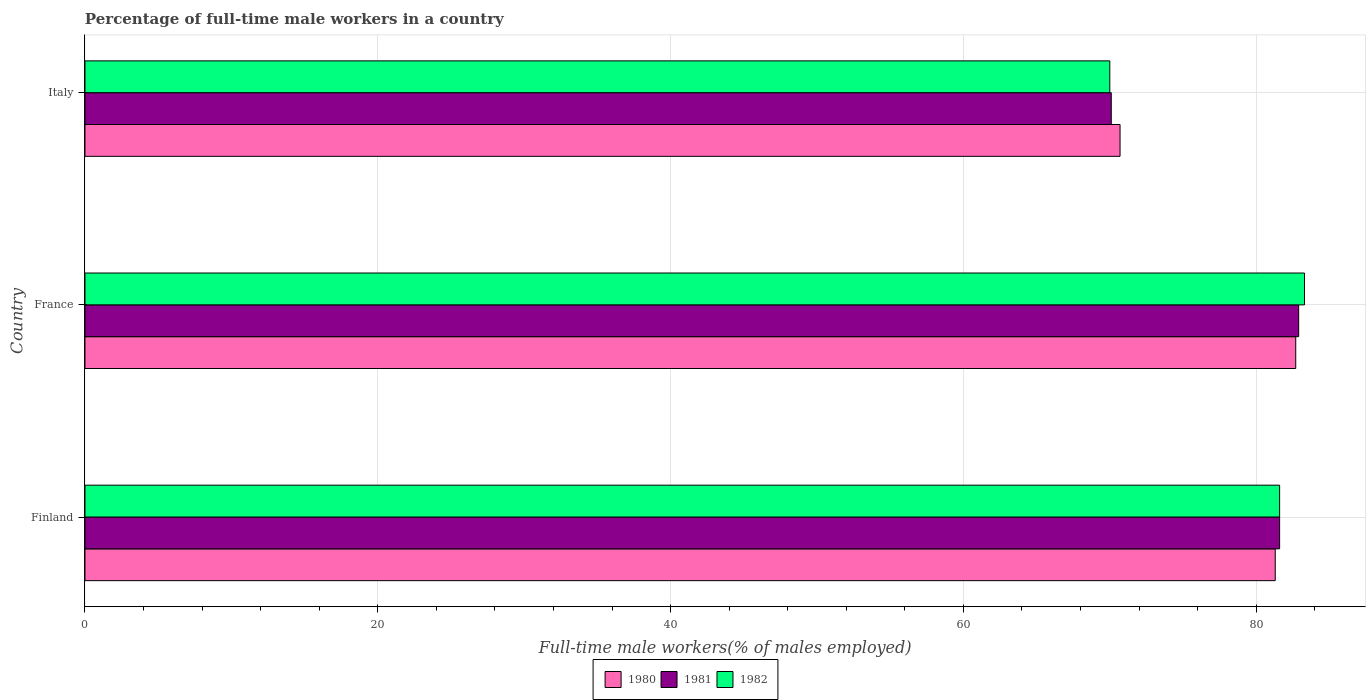How many different coloured bars are there?
Make the answer very short. 3. How many groups of bars are there?
Your response must be concise. 3. Are the number of bars per tick equal to the number of legend labels?
Give a very brief answer. Yes. How many bars are there on the 1st tick from the bottom?
Provide a short and direct response. 3. What is the label of the 3rd group of bars from the top?
Offer a very short reply. Finland. In how many cases, is the number of bars for a given country not equal to the number of legend labels?
Your answer should be very brief. 0. What is the percentage of full-time male workers in 1981 in Italy?
Keep it short and to the point. 70.1. Across all countries, what is the maximum percentage of full-time male workers in 1982?
Provide a succinct answer. 83.3. Across all countries, what is the minimum percentage of full-time male workers in 1981?
Provide a short and direct response. 70.1. In which country was the percentage of full-time male workers in 1982 maximum?
Your answer should be compact. France. What is the total percentage of full-time male workers in 1981 in the graph?
Make the answer very short. 234.6. What is the difference between the percentage of full-time male workers in 1981 in Finland and that in Italy?
Keep it short and to the point. 11.5. What is the difference between the percentage of full-time male workers in 1982 in Italy and the percentage of full-time male workers in 1981 in France?
Your answer should be compact. -12.9. What is the average percentage of full-time male workers in 1981 per country?
Offer a very short reply. 78.2. What is the difference between the percentage of full-time male workers in 1980 and percentage of full-time male workers in 1982 in Italy?
Your answer should be compact. 0.7. What is the ratio of the percentage of full-time male workers in 1980 in France to that in Italy?
Make the answer very short. 1.17. Is the percentage of full-time male workers in 1982 in Finland less than that in Italy?
Offer a terse response. No. What is the difference between the highest and the second highest percentage of full-time male workers in 1980?
Make the answer very short. 1.4. What is the difference between the highest and the lowest percentage of full-time male workers in 1982?
Your response must be concise. 13.3. Is the sum of the percentage of full-time male workers in 1982 in Finland and France greater than the maximum percentage of full-time male workers in 1981 across all countries?
Offer a terse response. Yes. What does the 3rd bar from the top in Finland represents?
Keep it short and to the point. 1980. What does the 3rd bar from the bottom in Italy represents?
Ensure brevity in your answer.  1982. What is the difference between two consecutive major ticks on the X-axis?
Provide a succinct answer. 20. Are the values on the major ticks of X-axis written in scientific E-notation?
Ensure brevity in your answer.  No. How many legend labels are there?
Give a very brief answer. 3. How are the legend labels stacked?
Make the answer very short. Horizontal. What is the title of the graph?
Provide a succinct answer. Percentage of full-time male workers in a country. What is the label or title of the X-axis?
Keep it short and to the point. Full-time male workers(% of males employed). What is the Full-time male workers(% of males employed) of 1980 in Finland?
Offer a terse response. 81.3. What is the Full-time male workers(% of males employed) in 1981 in Finland?
Make the answer very short. 81.6. What is the Full-time male workers(% of males employed) in 1982 in Finland?
Offer a very short reply. 81.6. What is the Full-time male workers(% of males employed) of 1980 in France?
Make the answer very short. 82.7. What is the Full-time male workers(% of males employed) of 1981 in France?
Provide a short and direct response. 82.9. What is the Full-time male workers(% of males employed) of 1982 in France?
Offer a terse response. 83.3. What is the Full-time male workers(% of males employed) in 1980 in Italy?
Make the answer very short. 70.7. What is the Full-time male workers(% of males employed) of 1981 in Italy?
Your answer should be compact. 70.1. What is the Full-time male workers(% of males employed) of 1982 in Italy?
Make the answer very short. 70. Across all countries, what is the maximum Full-time male workers(% of males employed) in 1980?
Give a very brief answer. 82.7. Across all countries, what is the maximum Full-time male workers(% of males employed) in 1981?
Make the answer very short. 82.9. Across all countries, what is the maximum Full-time male workers(% of males employed) in 1982?
Make the answer very short. 83.3. Across all countries, what is the minimum Full-time male workers(% of males employed) in 1980?
Provide a short and direct response. 70.7. Across all countries, what is the minimum Full-time male workers(% of males employed) of 1981?
Provide a succinct answer. 70.1. Across all countries, what is the minimum Full-time male workers(% of males employed) in 1982?
Offer a very short reply. 70. What is the total Full-time male workers(% of males employed) in 1980 in the graph?
Your answer should be very brief. 234.7. What is the total Full-time male workers(% of males employed) in 1981 in the graph?
Ensure brevity in your answer.  234.6. What is the total Full-time male workers(% of males employed) in 1982 in the graph?
Your response must be concise. 234.9. What is the difference between the Full-time male workers(% of males employed) in 1980 in Finland and that in Italy?
Give a very brief answer. 10.6. What is the difference between the Full-time male workers(% of males employed) in 1982 in Finland and that in Italy?
Offer a very short reply. 11.6. What is the difference between the Full-time male workers(% of males employed) of 1980 in France and that in Italy?
Offer a very short reply. 12. What is the difference between the Full-time male workers(% of males employed) of 1982 in France and that in Italy?
Your answer should be compact. 13.3. What is the difference between the Full-time male workers(% of males employed) in 1980 in Finland and the Full-time male workers(% of males employed) in 1981 in France?
Provide a succinct answer. -1.6. What is the difference between the Full-time male workers(% of males employed) of 1981 in Finland and the Full-time male workers(% of males employed) of 1982 in France?
Ensure brevity in your answer.  -1.7. What is the difference between the Full-time male workers(% of males employed) of 1980 in Finland and the Full-time male workers(% of males employed) of 1981 in Italy?
Make the answer very short. 11.2. What is the difference between the Full-time male workers(% of males employed) in 1980 in Finland and the Full-time male workers(% of males employed) in 1982 in Italy?
Make the answer very short. 11.3. What is the difference between the Full-time male workers(% of males employed) in 1981 in Finland and the Full-time male workers(% of males employed) in 1982 in Italy?
Provide a short and direct response. 11.6. What is the difference between the Full-time male workers(% of males employed) of 1980 in France and the Full-time male workers(% of males employed) of 1981 in Italy?
Make the answer very short. 12.6. What is the difference between the Full-time male workers(% of males employed) in 1980 in France and the Full-time male workers(% of males employed) in 1982 in Italy?
Provide a succinct answer. 12.7. What is the difference between the Full-time male workers(% of males employed) of 1981 in France and the Full-time male workers(% of males employed) of 1982 in Italy?
Offer a terse response. 12.9. What is the average Full-time male workers(% of males employed) in 1980 per country?
Provide a short and direct response. 78.23. What is the average Full-time male workers(% of males employed) in 1981 per country?
Your answer should be compact. 78.2. What is the average Full-time male workers(% of males employed) of 1982 per country?
Offer a very short reply. 78.3. What is the difference between the Full-time male workers(% of males employed) of 1980 and Full-time male workers(% of males employed) of 1982 in Finland?
Your response must be concise. -0.3. What is the difference between the Full-time male workers(% of males employed) of 1981 and Full-time male workers(% of males employed) of 1982 in France?
Offer a terse response. -0.4. What is the ratio of the Full-time male workers(% of males employed) in 1980 in Finland to that in France?
Your answer should be compact. 0.98. What is the ratio of the Full-time male workers(% of males employed) in 1981 in Finland to that in France?
Your response must be concise. 0.98. What is the ratio of the Full-time male workers(% of males employed) in 1982 in Finland to that in France?
Your answer should be very brief. 0.98. What is the ratio of the Full-time male workers(% of males employed) in 1980 in Finland to that in Italy?
Make the answer very short. 1.15. What is the ratio of the Full-time male workers(% of males employed) of 1981 in Finland to that in Italy?
Your response must be concise. 1.16. What is the ratio of the Full-time male workers(% of males employed) of 1982 in Finland to that in Italy?
Make the answer very short. 1.17. What is the ratio of the Full-time male workers(% of males employed) of 1980 in France to that in Italy?
Make the answer very short. 1.17. What is the ratio of the Full-time male workers(% of males employed) of 1981 in France to that in Italy?
Make the answer very short. 1.18. What is the ratio of the Full-time male workers(% of males employed) in 1982 in France to that in Italy?
Offer a terse response. 1.19. What is the difference between the highest and the second highest Full-time male workers(% of males employed) in 1981?
Your answer should be very brief. 1.3. What is the difference between the highest and the lowest Full-time male workers(% of males employed) in 1980?
Your answer should be very brief. 12. What is the difference between the highest and the lowest Full-time male workers(% of males employed) of 1982?
Your answer should be very brief. 13.3. 